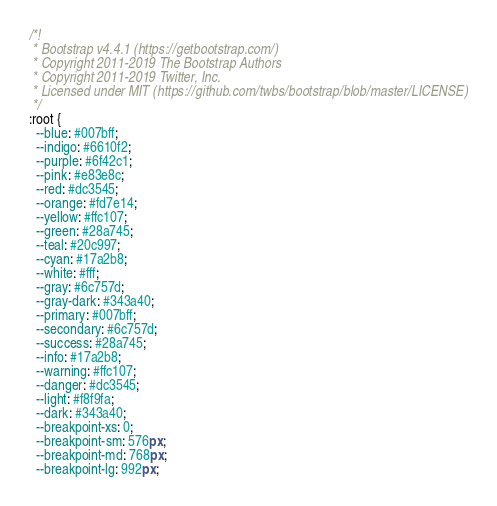<code> <loc_0><loc_0><loc_500><loc_500><_CSS_>/*!
 * Bootstrap v4.4.1 (https://getbootstrap.com/)
 * Copyright 2011-2019 The Bootstrap Authors
 * Copyright 2011-2019 Twitter, Inc.
 * Licensed under MIT (https://github.com/twbs/bootstrap/blob/master/LICENSE)
 */
:root {
  --blue: #007bff;
  --indigo: #6610f2;
  --purple: #6f42c1;
  --pink: #e83e8c;
  --red: #dc3545;
  --orange: #fd7e14;
  --yellow: #ffc107;
  --green: #28a745;
  --teal: #20c997;
  --cyan: #17a2b8;
  --white: #fff;
  --gray: #6c757d;
  --gray-dark: #343a40;
  --primary: #007bff;
  --secondary: #6c757d;
  --success: #28a745;
  --info: #17a2b8;
  --warning: #ffc107;
  --danger: #dc3545;
  --light: #f8f9fa;
  --dark: #343a40;
  --breakpoint-xs: 0;
  --breakpoint-sm: 576px;
  --breakpoint-md: 768px;
  --breakpoint-lg: 992px;</code> 